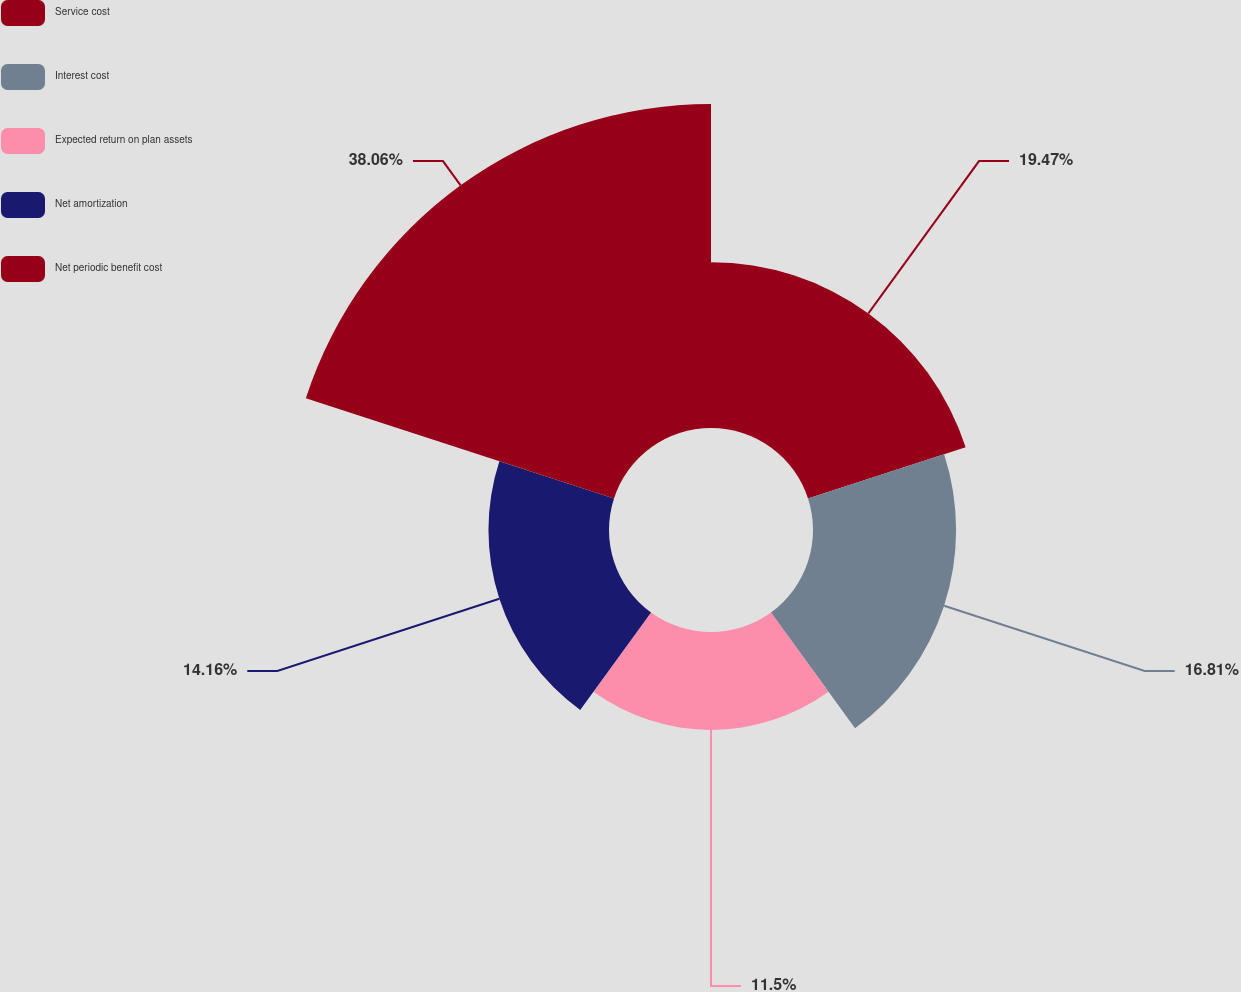Convert chart. <chart><loc_0><loc_0><loc_500><loc_500><pie_chart><fcel>Service cost<fcel>Interest cost<fcel>Expected return on plan assets<fcel>Net amortization<fcel>Net periodic benefit cost<nl><fcel>19.47%<fcel>16.81%<fcel>11.5%<fcel>14.16%<fcel>38.06%<nl></chart> 